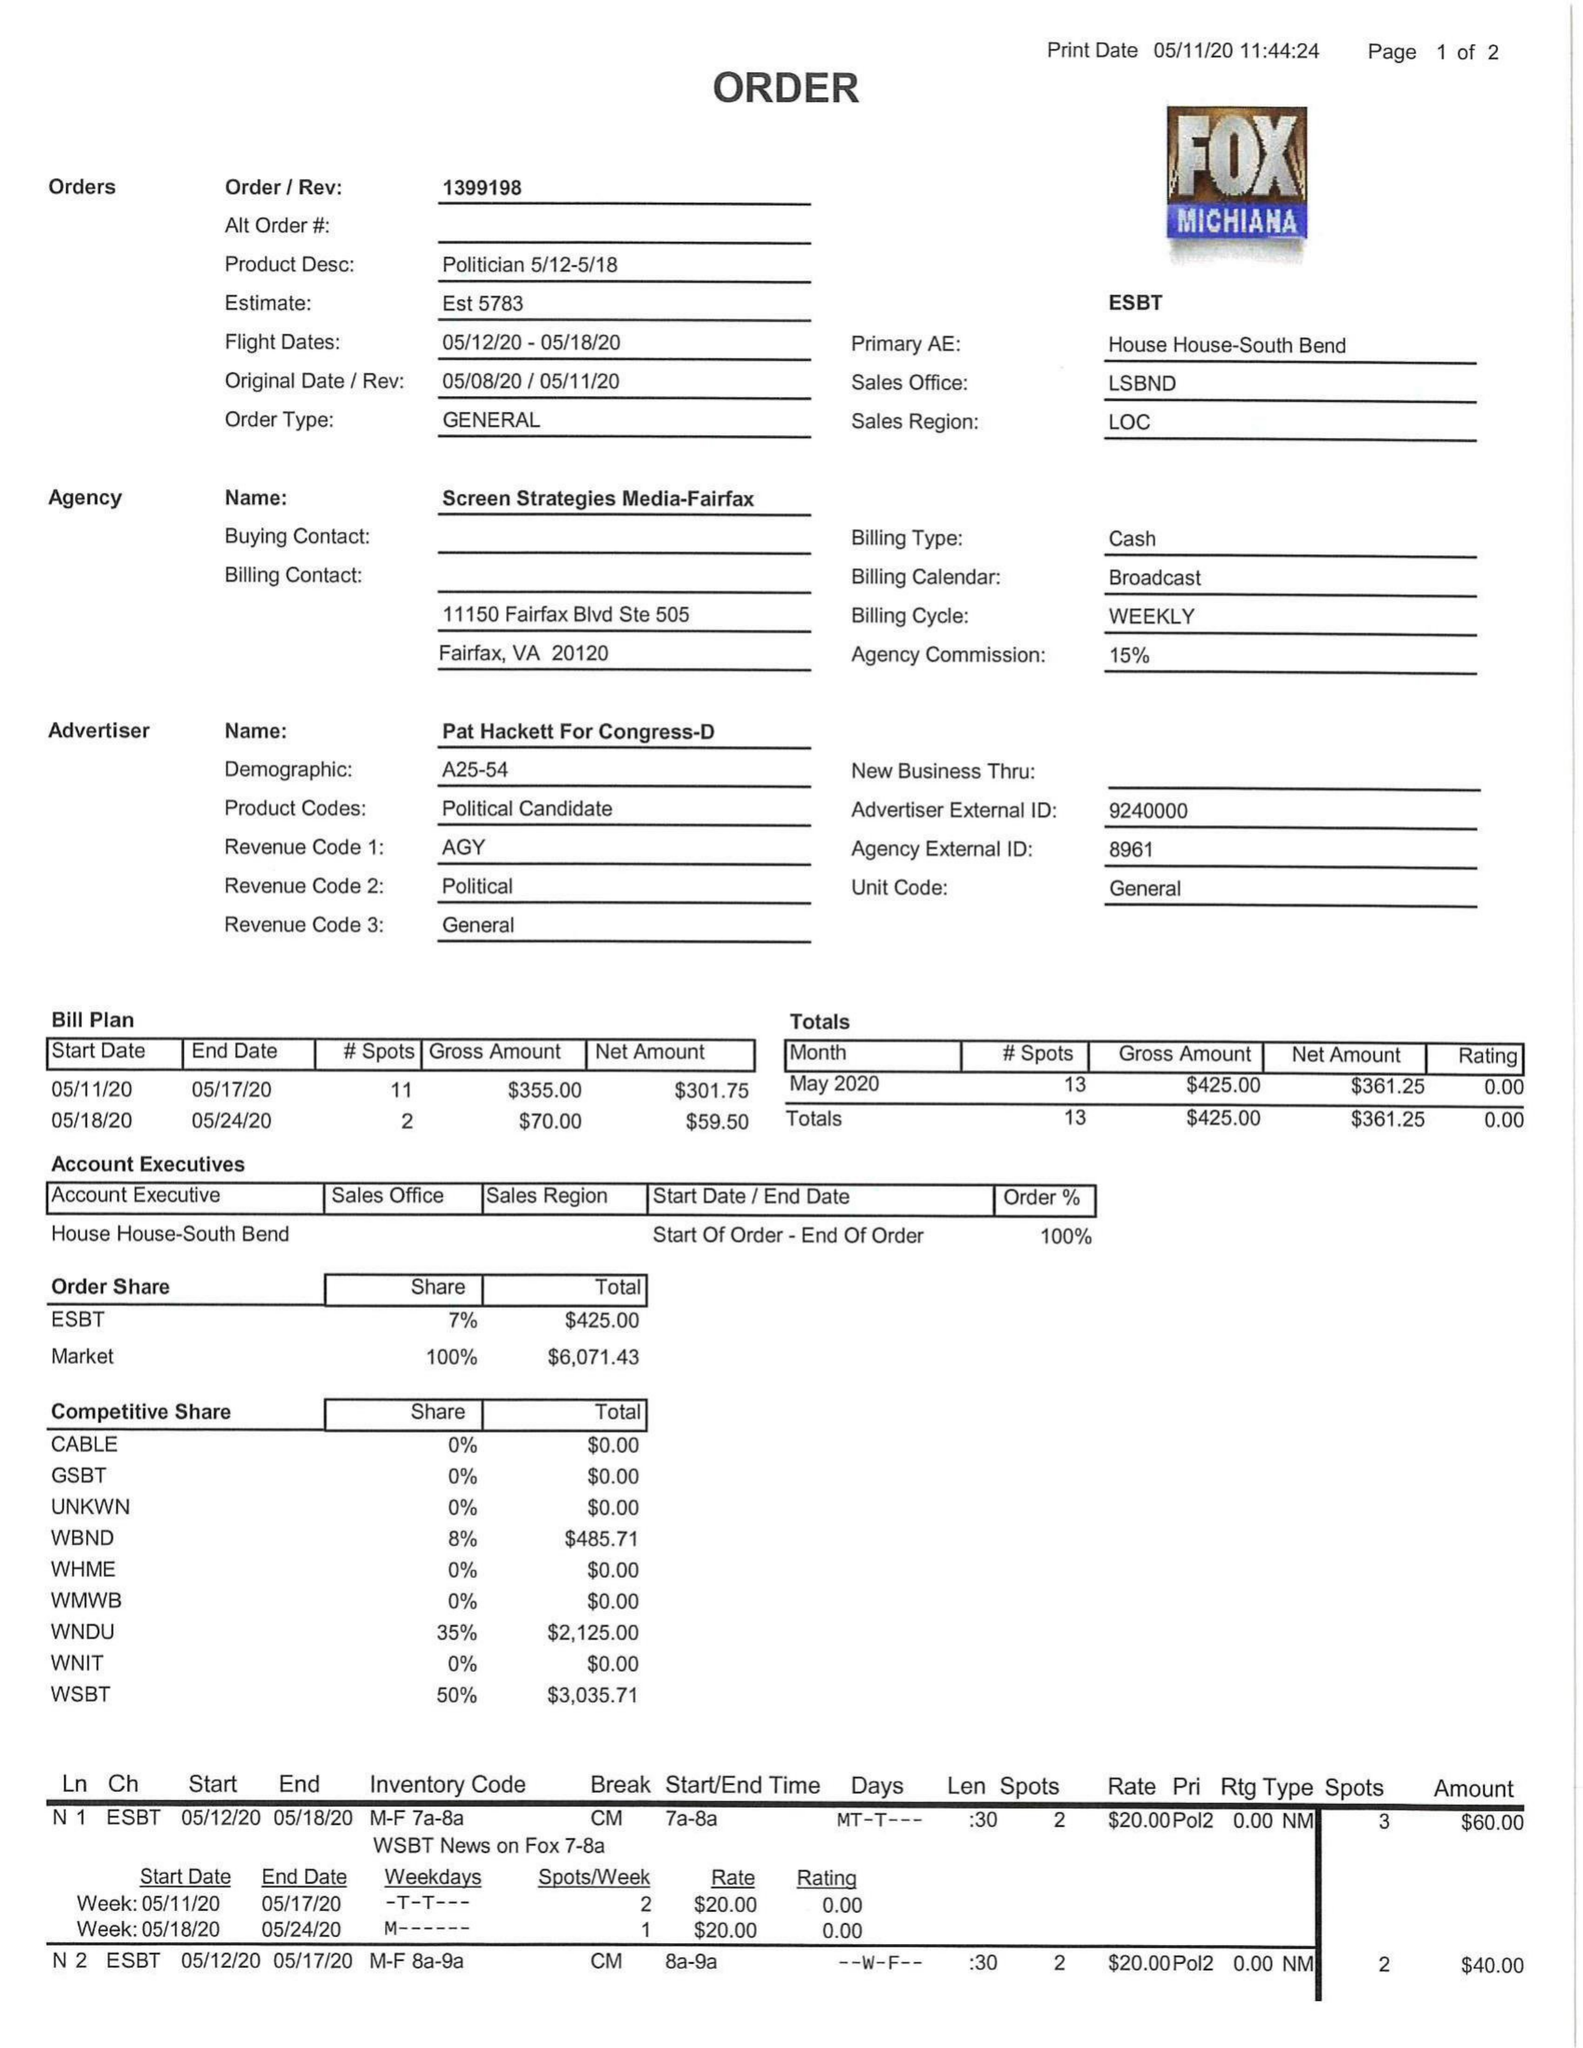What is the value for the flight_to?
Answer the question using a single word or phrase. 05/18/20 